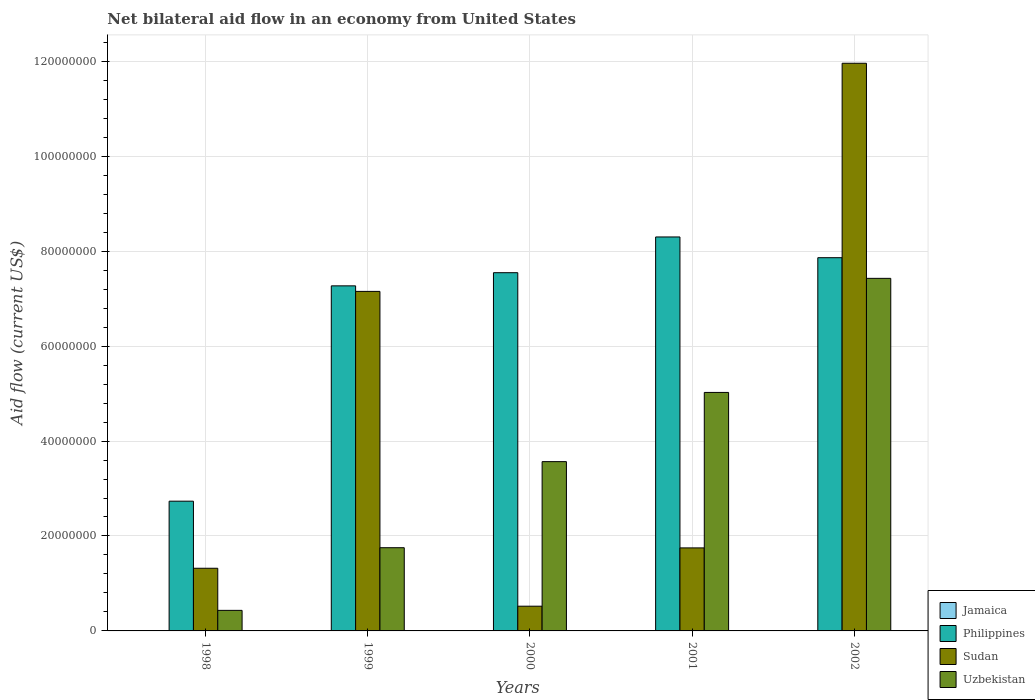How many different coloured bars are there?
Your answer should be very brief. 3. How many groups of bars are there?
Your answer should be compact. 5. Are the number of bars on each tick of the X-axis equal?
Provide a succinct answer. Yes. How many bars are there on the 3rd tick from the left?
Give a very brief answer. 3. What is the label of the 3rd group of bars from the left?
Offer a terse response. 2000. What is the net bilateral aid flow in Uzbekistan in 2002?
Ensure brevity in your answer.  7.43e+07. Across all years, what is the maximum net bilateral aid flow in Philippines?
Offer a terse response. 8.30e+07. Across all years, what is the minimum net bilateral aid flow in Uzbekistan?
Your answer should be very brief. 4.33e+06. What is the total net bilateral aid flow in Philippines in the graph?
Offer a terse response. 3.37e+08. What is the difference between the net bilateral aid flow in Philippines in 2000 and that in 2002?
Ensure brevity in your answer.  -3.16e+06. What is the difference between the net bilateral aid flow in Philippines in 2001 and the net bilateral aid flow in Uzbekistan in 2002?
Keep it short and to the point. 8.72e+06. What is the average net bilateral aid flow in Uzbekistan per year?
Your response must be concise. 3.64e+07. In the year 2001, what is the difference between the net bilateral aid flow in Uzbekistan and net bilateral aid flow in Philippines?
Offer a very short reply. -3.28e+07. What is the ratio of the net bilateral aid flow in Philippines in 1998 to that in 2001?
Give a very brief answer. 0.33. Is the net bilateral aid flow in Uzbekistan in 1998 less than that in 2002?
Provide a succinct answer. Yes. What is the difference between the highest and the second highest net bilateral aid flow in Philippines?
Keep it short and to the point. 4.37e+06. What is the difference between the highest and the lowest net bilateral aid flow in Philippines?
Ensure brevity in your answer.  5.57e+07. Is it the case that in every year, the sum of the net bilateral aid flow in Uzbekistan and net bilateral aid flow in Jamaica is greater than the net bilateral aid flow in Philippines?
Provide a short and direct response. No. How many bars are there?
Ensure brevity in your answer.  15. How many years are there in the graph?
Offer a terse response. 5. Are the values on the major ticks of Y-axis written in scientific E-notation?
Make the answer very short. No. Does the graph contain any zero values?
Keep it short and to the point. Yes. Does the graph contain grids?
Offer a very short reply. Yes. How many legend labels are there?
Offer a terse response. 4. What is the title of the graph?
Your response must be concise. Net bilateral aid flow in an economy from United States. Does "Barbados" appear as one of the legend labels in the graph?
Give a very brief answer. No. What is the Aid flow (current US$) in Jamaica in 1998?
Provide a short and direct response. 0. What is the Aid flow (current US$) in Philippines in 1998?
Provide a succinct answer. 2.73e+07. What is the Aid flow (current US$) of Sudan in 1998?
Offer a terse response. 1.32e+07. What is the Aid flow (current US$) in Uzbekistan in 1998?
Ensure brevity in your answer.  4.33e+06. What is the Aid flow (current US$) of Philippines in 1999?
Your response must be concise. 7.27e+07. What is the Aid flow (current US$) of Sudan in 1999?
Ensure brevity in your answer.  7.15e+07. What is the Aid flow (current US$) in Uzbekistan in 1999?
Provide a short and direct response. 1.75e+07. What is the Aid flow (current US$) in Jamaica in 2000?
Your answer should be compact. 0. What is the Aid flow (current US$) in Philippines in 2000?
Provide a succinct answer. 7.55e+07. What is the Aid flow (current US$) in Sudan in 2000?
Provide a short and direct response. 5.21e+06. What is the Aid flow (current US$) in Uzbekistan in 2000?
Make the answer very short. 3.57e+07. What is the Aid flow (current US$) of Jamaica in 2001?
Offer a very short reply. 0. What is the Aid flow (current US$) of Philippines in 2001?
Ensure brevity in your answer.  8.30e+07. What is the Aid flow (current US$) of Sudan in 2001?
Provide a short and direct response. 1.75e+07. What is the Aid flow (current US$) in Uzbekistan in 2001?
Your answer should be very brief. 5.02e+07. What is the Aid flow (current US$) of Philippines in 2002?
Keep it short and to the point. 7.86e+07. What is the Aid flow (current US$) in Sudan in 2002?
Provide a short and direct response. 1.20e+08. What is the Aid flow (current US$) in Uzbekistan in 2002?
Give a very brief answer. 7.43e+07. Across all years, what is the maximum Aid flow (current US$) in Philippines?
Keep it short and to the point. 8.30e+07. Across all years, what is the maximum Aid flow (current US$) of Sudan?
Keep it short and to the point. 1.20e+08. Across all years, what is the maximum Aid flow (current US$) of Uzbekistan?
Offer a very short reply. 7.43e+07. Across all years, what is the minimum Aid flow (current US$) of Philippines?
Provide a succinct answer. 2.73e+07. Across all years, what is the minimum Aid flow (current US$) of Sudan?
Your answer should be very brief. 5.21e+06. Across all years, what is the minimum Aid flow (current US$) in Uzbekistan?
Provide a succinct answer. 4.33e+06. What is the total Aid flow (current US$) in Philippines in the graph?
Give a very brief answer. 3.37e+08. What is the total Aid flow (current US$) of Sudan in the graph?
Make the answer very short. 2.27e+08. What is the total Aid flow (current US$) of Uzbekistan in the graph?
Provide a succinct answer. 1.82e+08. What is the difference between the Aid flow (current US$) in Philippines in 1998 and that in 1999?
Ensure brevity in your answer.  -4.54e+07. What is the difference between the Aid flow (current US$) of Sudan in 1998 and that in 1999?
Ensure brevity in your answer.  -5.83e+07. What is the difference between the Aid flow (current US$) in Uzbekistan in 1998 and that in 1999?
Offer a very short reply. -1.32e+07. What is the difference between the Aid flow (current US$) of Philippines in 1998 and that in 2000?
Keep it short and to the point. -4.81e+07. What is the difference between the Aid flow (current US$) of Sudan in 1998 and that in 2000?
Keep it short and to the point. 7.99e+06. What is the difference between the Aid flow (current US$) of Uzbekistan in 1998 and that in 2000?
Your answer should be compact. -3.13e+07. What is the difference between the Aid flow (current US$) of Philippines in 1998 and that in 2001?
Provide a succinct answer. -5.57e+07. What is the difference between the Aid flow (current US$) of Sudan in 1998 and that in 2001?
Your answer should be very brief. -4.29e+06. What is the difference between the Aid flow (current US$) in Uzbekistan in 1998 and that in 2001?
Your response must be concise. -4.59e+07. What is the difference between the Aid flow (current US$) in Philippines in 1998 and that in 2002?
Keep it short and to the point. -5.13e+07. What is the difference between the Aid flow (current US$) of Sudan in 1998 and that in 2002?
Your answer should be very brief. -1.06e+08. What is the difference between the Aid flow (current US$) of Uzbekistan in 1998 and that in 2002?
Provide a short and direct response. -6.99e+07. What is the difference between the Aid flow (current US$) in Philippines in 1999 and that in 2000?
Make the answer very short. -2.77e+06. What is the difference between the Aid flow (current US$) in Sudan in 1999 and that in 2000?
Offer a very short reply. 6.63e+07. What is the difference between the Aid flow (current US$) in Uzbekistan in 1999 and that in 2000?
Give a very brief answer. -1.81e+07. What is the difference between the Aid flow (current US$) of Philippines in 1999 and that in 2001?
Offer a terse response. -1.03e+07. What is the difference between the Aid flow (current US$) of Sudan in 1999 and that in 2001?
Offer a terse response. 5.40e+07. What is the difference between the Aid flow (current US$) in Uzbekistan in 1999 and that in 2001?
Your response must be concise. -3.27e+07. What is the difference between the Aid flow (current US$) in Philippines in 1999 and that in 2002?
Ensure brevity in your answer.  -5.93e+06. What is the difference between the Aid flow (current US$) in Sudan in 1999 and that in 2002?
Give a very brief answer. -4.81e+07. What is the difference between the Aid flow (current US$) of Uzbekistan in 1999 and that in 2002?
Your answer should be very brief. -5.67e+07. What is the difference between the Aid flow (current US$) in Philippines in 2000 and that in 2001?
Your answer should be compact. -7.53e+06. What is the difference between the Aid flow (current US$) of Sudan in 2000 and that in 2001?
Your answer should be compact. -1.23e+07. What is the difference between the Aid flow (current US$) of Uzbekistan in 2000 and that in 2001?
Provide a short and direct response. -1.46e+07. What is the difference between the Aid flow (current US$) of Philippines in 2000 and that in 2002?
Offer a very short reply. -3.16e+06. What is the difference between the Aid flow (current US$) of Sudan in 2000 and that in 2002?
Give a very brief answer. -1.14e+08. What is the difference between the Aid flow (current US$) of Uzbekistan in 2000 and that in 2002?
Provide a short and direct response. -3.86e+07. What is the difference between the Aid flow (current US$) of Philippines in 2001 and that in 2002?
Provide a short and direct response. 4.37e+06. What is the difference between the Aid flow (current US$) of Sudan in 2001 and that in 2002?
Give a very brief answer. -1.02e+08. What is the difference between the Aid flow (current US$) in Uzbekistan in 2001 and that in 2002?
Keep it short and to the point. -2.40e+07. What is the difference between the Aid flow (current US$) in Philippines in 1998 and the Aid flow (current US$) in Sudan in 1999?
Provide a succinct answer. -4.42e+07. What is the difference between the Aid flow (current US$) in Philippines in 1998 and the Aid flow (current US$) in Uzbekistan in 1999?
Ensure brevity in your answer.  9.80e+06. What is the difference between the Aid flow (current US$) in Sudan in 1998 and the Aid flow (current US$) in Uzbekistan in 1999?
Keep it short and to the point. -4.33e+06. What is the difference between the Aid flow (current US$) of Philippines in 1998 and the Aid flow (current US$) of Sudan in 2000?
Give a very brief answer. 2.21e+07. What is the difference between the Aid flow (current US$) of Philippines in 1998 and the Aid flow (current US$) of Uzbekistan in 2000?
Your answer should be very brief. -8.33e+06. What is the difference between the Aid flow (current US$) in Sudan in 1998 and the Aid flow (current US$) in Uzbekistan in 2000?
Ensure brevity in your answer.  -2.25e+07. What is the difference between the Aid flow (current US$) of Philippines in 1998 and the Aid flow (current US$) of Sudan in 2001?
Offer a very short reply. 9.84e+06. What is the difference between the Aid flow (current US$) of Philippines in 1998 and the Aid flow (current US$) of Uzbekistan in 2001?
Provide a short and direct response. -2.29e+07. What is the difference between the Aid flow (current US$) of Sudan in 1998 and the Aid flow (current US$) of Uzbekistan in 2001?
Your answer should be compact. -3.70e+07. What is the difference between the Aid flow (current US$) in Philippines in 1998 and the Aid flow (current US$) in Sudan in 2002?
Provide a short and direct response. -9.22e+07. What is the difference between the Aid flow (current US$) in Philippines in 1998 and the Aid flow (current US$) in Uzbekistan in 2002?
Make the answer very short. -4.69e+07. What is the difference between the Aid flow (current US$) in Sudan in 1998 and the Aid flow (current US$) in Uzbekistan in 2002?
Offer a terse response. -6.11e+07. What is the difference between the Aid flow (current US$) of Philippines in 1999 and the Aid flow (current US$) of Sudan in 2000?
Your answer should be very brief. 6.75e+07. What is the difference between the Aid flow (current US$) of Philippines in 1999 and the Aid flow (current US$) of Uzbekistan in 2000?
Offer a terse response. 3.70e+07. What is the difference between the Aid flow (current US$) in Sudan in 1999 and the Aid flow (current US$) in Uzbekistan in 2000?
Offer a terse response. 3.59e+07. What is the difference between the Aid flow (current US$) in Philippines in 1999 and the Aid flow (current US$) in Sudan in 2001?
Offer a terse response. 5.52e+07. What is the difference between the Aid flow (current US$) in Philippines in 1999 and the Aid flow (current US$) in Uzbekistan in 2001?
Your answer should be very brief. 2.24e+07. What is the difference between the Aid flow (current US$) of Sudan in 1999 and the Aid flow (current US$) of Uzbekistan in 2001?
Provide a succinct answer. 2.13e+07. What is the difference between the Aid flow (current US$) in Philippines in 1999 and the Aid flow (current US$) in Sudan in 2002?
Provide a succinct answer. -4.69e+07. What is the difference between the Aid flow (current US$) in Philippines in 1999 and the Aid flow (current US$) in Uzbekistan in 2002?
Your response must be concise. -1.58e+06. What is the difference between the Aid flow (current US$) of Sudan in 1999 and the Aid flow (current US$) of Uzbekistan in 2002?
Provide a short and direct response. -2.75e+06. What is the difference between the Aid flow (current US$) of Philippines in 2000 and the Aid flow (current US$) of Sudan in 2001?
Ensure brevity in your answer.  5.80e+07. What is the difference between the Aid flow (current US$) in Philippines in 2000 and the Aid flow (current US$) in Uzbekistan in 2001?
Ensure brevity in your answer.  2.52e+07. What is the difference between the Aid flow (current US$) in Sudan in 2000 and the Aid flow (current US$) in Uzbekistan in 2001?
Your response must be concise. -4.50e+07. What is the difference between the Aid flow (current US$) of Philippines in 2000 and the Aid flow (current US$) of Sudan in 2002?
Offer a terse response. -4.41e+07. What is the difference between the Aid flow (current US$) of Philippines in 2000 and the Aid flow (current US$) of Uzbekistan in 2002?
Offer a terse response. 1.19e+06. What is the difference between the Aid flow (current US$) in Sudan in 2000 and the Aid flow (current US$) in Uzbekistan in 2002?
Your answer should be compact. -6.91e+07. What is the difference between the Aid flow (current US$) in Philippines in 2001 and the Aid flow (current US$) in Sudan in 2002?
Give a very brief answer. -3.66e+07. What is the difference between the Aid flow (current US$) of Philippines in 2001 and the Aid flow (current US$) of Uzbekistan in 2002?
Give a very brief answer. 8.72e+06. What is the difference between the Aid flow (current US$) of Sudan in 2001 and the Aid flow (current US$) of Uzbekistan in 2002?
Provide a short and direct response. -5.68e+07. What is the average Aid flow (current US$) of Philippines per year?
Offer a very short reply. 6.74e+07. What is the average Aid flow (current US$) in Sudan per year?
Provide a succinct answer. 4.54e+07. What is the average Aid flow (current US$) of Uzbekistan per year?
Keep it short and to the point. 3.64e+07. In the year 1998, what is the difference between the Aid flow (current US$) of Philippines and Aid flow (current US$) of Sudan?
Offer a very short reply. 1.41e+07. In the year 1998, what is the difference between the Aid flow (current US$) of Philippines and Aid flow (current US$) of Uzbekistan?
Offer a terse response. 2.30e+07. In the year 1998, what is the difference between the Aid flow (current US$) in Sudan and Aid flow (current US$) in Uzbekistan?
Ensure brevity in your answer.  8.87e+06. In the year 1999, what is the difference between the Aid flow (current US$) of Philippines and Aid flow (current US$) of Sudan?
Your answer should be compact. 1.17e+06. In the year 1999, what is the difference between the Aid flow (current US$) in Philippines and Aid flow (current US$) in Uzbekistan?
Your answer should be compact. 5.52e+07. In the year 1999, what is the difference between the Aid flow (current US$) in Sudan and Aid flow (current US$) in Uzbekistan?
Give a very brief answer. 5.40e+07. In the year 2000, what is the difference between the Aid flow (current US$) in Philippines and Aid flow (current US$) in Sudan?
Your answer should be very brief. 7.02e+07. In the year 2000, what is the difference between the Aid flow (current US$) of Philippines and Aid flow (current US$) of Uzbekistan?
Offer a very short reply. 3.98e+07. In the year 2000, what is the difference between the Aid flow (current US$) of Sudan and Aid flow (current US$) of Uzbekistan?
Offer a terse response. -3.04e+07. In the year 2001, what is the difference between the Aid flow (current US$) in Philippines and Aid flow (current US$) in Sudan?
Provide a short and direct response. 6.55e+07. In the year 2001, what is the difference between the Aid flow (current US$) of Philippines and Aid flow (current US$) of Uzbekistan?
Provide a short and direct response. 3.28e+07. In the year 2001, what is the difference between the Aid flow (current US$) in Sudan and Aid flow (current US$) in Uzbekistan?
Offer a very short reply. -3.28e+07. In the year 2002, what is the difference between the Aid flow (current US$) of Philippines and Aid flow (current US$) of Sudan?
Make the answer very short. -4.10e+07. In the year 2002, what is the difference between the Aid flow (current US$) of Philippines and Aid flow (current US$) of Uzbekistan?
Offer a terse response. 4.35e+06. In the year 2002, what is the difference between the Aid flow (current US$) in Sudan and Aid flow (current US$) in Uzbekistan?
Provide a succinct answer. 4.53e+07. What is the ratio of the Aid flow (current US$) in Philippines in 1998 to that in 1999?
Make the answer very short. 0.38. What is the ratio of the Aid flow (current US$) of Sudan in 1998 to that in 1999?
Provide a succinct answer. 0.18. What is the ratio of the Aid flow (current US$) of Uzbekistan in 1998 to that in 1999?
Your answer should be compact. 0.25. What is the ratio of the Aid flow (current US$) of Philippines in 1998 to that in 2000?
Offer a terse response. 0.36. What is the ratio of the Aid flow (current US$) of Sudan in 1998 to that in 2000?
Offer a very short reply. 2.53. What is the ratio of the Aid flow (current US$) of Uzbekistan in 1998 to that in 2000?
Provide a succinct answer. 0.12. What is the ratio of the Aid flow (current US$) in Philippines in 1998 to that in 2001?
Offer a terse response. 0.33. What is the ratio of the Aid flow (current US$) in Sudan in 1998 to that in 2001?
Make the answer very short. 0.75. What is the ratio of the Aid flow (current US$) in Uzbekistan in 1998 to that in 2001?
Ensure brevity in your answer.  0.09. What is the ratio of the Aid flow (current US$) in Philippines in 1998 to that in 2002?
Your answer should be very brief. 0.35. What is the ratio of the Aid flow (current US$) of Sudan in 1998 to that in 2002?
Ensure brevity in your answer.  0.11. What is the ratio of the Aid flow (current US$) in Uzbekistan in 1998 to that in 2002?
Offer a very short reply. 0.06. What is the ratio of the Aid flow (current US$) in Philippines in 1999 to that in 2000?
Give a very brief answer. 0.96. What is the ratio of the Aid flow (current US$) of Sudan in 1999 to that in 2000?
Your answer should be compact. 13.73. What is the ratio of the Aid flow (current US$) in Uzbekistan in 1999 to that in 2000?
Ensure brevity in your answer.  0.49. What is the ratio of the Aid flow (current US$) of Philippines in 1999 to that in 2001?
Ensure brevity in your answer.  0.88. What is the ratio of the Aid flow (current US$) of Sudan in 1999 to that in 2001?
Your response must be concise. 4.09. What is the ratio of the Aid flow (current US$) of Uzbekistan in 1999 to that in 2001?
Keep it short and to the point. 0.35. What is the ratio of the Aid flow (current US$) of Philippines in 1999 to that in 2002?
Make the answer very short. 0.92. What is the ratio of the Aid flow (current US$) of Sudan in 1999 to that in 2002?
Make the answer very short. 0.6. What is the ratio of the Aid flow (current US$) in Uzbekistan in 1999 to that in 2002?
Your response must be concise. 0.24. What is the ratio of the Aid flow (current US$) of Philippines in 2000 to that in 2001?
Ensure brevity in your answer.  0.91. What is the ratio of the Aid flow (current US$) in Sudan in 2000 to that in 2001?
Offer a very short reply. 0.3. What is the ratio of the Aid flow (current US$) of Uzbekistan in 2000 to that in 2001?
Provide a succinct answer. 0.71. What is the ratio of the Aid flow (current US$) of Philippines in 2000 to that in 2002?
Make the answer very short. 0.96. What is the ratio of the Aid flow (current US$) of Sudan in 2000 to that in 2002?
Provide a short and direct response. 0.04. What is the ratio of the Aid flow (current US$) in Uzbekistan in 2000 to that in 2002?
Your answer should be compact. 0.48. What is the ratio of the Aid flow (current US$) of Philippines in 2001 to that in 2002?
Your answer should be compact. 1.06. What is the ratio of the Aid flow (current US$) in Sudan in 2001 to that in 2002?
Offer a very short reply. 0.15. What is the ratio of the Aid flow (current US$) of Uzbekistan in 2001 to that in 2002?
Your answer should be compact. 0.68. What is the difference between the highest and the second highest Aid flow (current US$) of Philippines?
Give a very brief answer. 4.37e+06. What is the difference between the highest and the second highest Aid flow (current US$) in Sudan?
Provide a short and direct response. 4.81e+07. What is the difference between the highest and the second highest Aid flow (current US$) of Uzbekistan?
Your answer should be very brief. 2.40e+07. What is the difference between the highest and the lowest Aid flow (current US$) of Philippines?
Provide a short and direct response. 5.57e+07. What is the difference between the highest and the lowest Aid flow (current US$) of Sudan?
Make the answer very short. 1.14e+08. What is the difference between the highest and the lowest Aid flow (current US$) of Uzbekistan?
Your answer should be compact. 6.99e+07. 